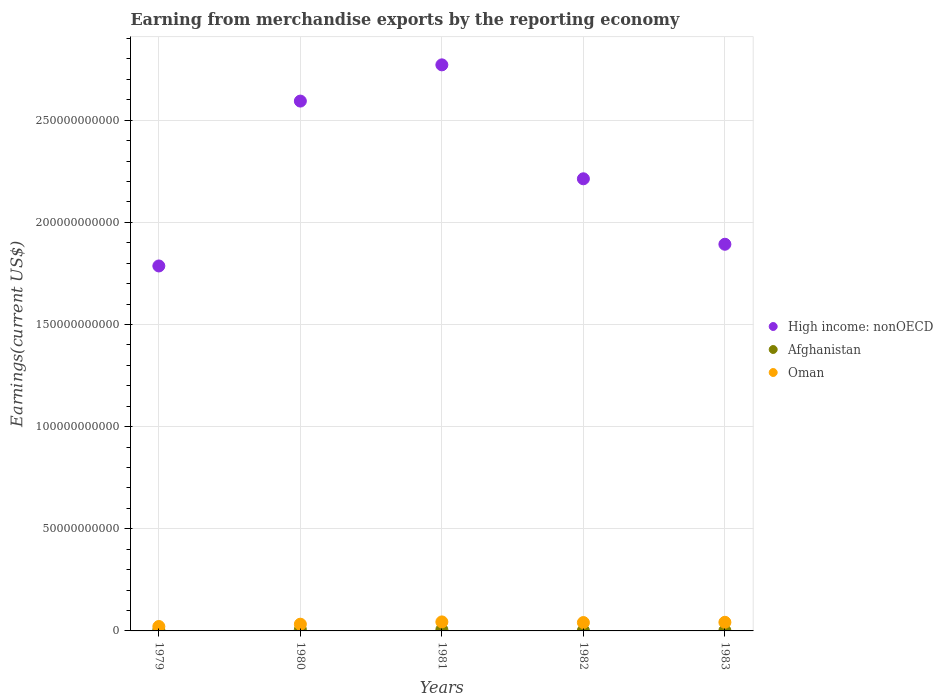Is the number of dotlines equal to the number of legend labels?
Give a very brief answer. Yes. What is the amount earned from merchandise exports in Afghanistan in 1982?
Offer a terse response. 2.01e+08. Across all years, what is the maximum amount earned from merchandise exports in Afghanistan?
Provide a succinct answer. 6.70e+08. Across all years, what is the minimum amount earned from merchandise exports in Afghanistan?
Offer a terse response. 1.95e+08. In which year was the amount earned from merchandise exports in Afghanistan minimum?
Keep it short and to the point. 1983. What is the total amount earned from merchandise exports in High income: nonOECD in the graph?
Provide a succinct answer. 1.13e+12. What is the difference between the amount earned from merchandise exports in Afghanistan in 1980 and that in 1981?
Make the answer very short. 3.24e+07. What is the difference between the amount earned from merchandise exports in High income: nonOECD in 1979 and the amount earned from merchandise exports in Afghanistan in 1980?
Provide a succinct answer. 1.78e+11. What is the average amount earned from merchandise exports in High income: nonOECD per year?
Offer a very short reply. 2.25e+11. In the year 1981, what is the difference between the amount earned from merchandise exports in High income: nonOECD and amount earned from merchandise exports in Oman?
Your response must be concise. 2.73e+11. In how many years, is the amount earned from merchandise exports in Afghanistan greater than 60000000000 US$?
Your answer should be compact. 0. What is the ratio of the amount earned from merchandise exports in High income: nonOECD in 1980 to that in 1981?
Make the answer very short. 0.94. Is the amount earned from merchandise exports in Oman in 1980 less than that in 1982?
Your answer should be compact. Yes. Is the difference between the amount earned from merchandise exports in High income: nonOECD in 1979 and 1980 greater than the difference between the amount earned from merchandise exports in Oman in 1979 and 1980?
Your response must be concise. No. What is the difference between the highest and the second highest amount earned from merchandise exports in High income: nonOECD?
Ensure brevity in your answer.  1.77e+1. What is the difference between the highest and the lowest amount earned from merchandise exports in High income: nonOECD?
Give a very brief answer. 9.84e+1. Is the sum of the amount earned from merchandise exports in Afghanistan in 1979 and 1981 greater than the maximum amount earned from merchandise exports in High income: nonOECD across all years?
Your answer should be compact. No. Does the amount earned from merchandise exports in Afghanistan monotonically increase over the years?
Ensure brevity in your answer.  No. How many years are there in the graph?
Offer a very short reply. 5. What is the difference between two consecutive major ticks on the Y-axis?
Give a very brief answer. 5.00e+1. Are the values on the major ticks of Y-axis written in scientific E-notation?
Offer a very short reply. No. Where does the legend appear in the graph?
Your answer should be very brief. Center right. How are the legend labels stacked?
Your response must be concise. Vertical. What is the title of the graph?
Offer a very short reply. Earning from merchandise exports by the reporting economy. What is the label or title of the Y-axis?
Your response must be concise. Earnings(current US$). What is the Earnings(current US$) of High income: nonOECD in 1979?
Offer a terse response. 1.79e+11. What is the Earnings(current US$) in Afghanistan in 1979?
Offer a terse response. 4.35e+08. What is the Earnings(current US$) in Oman in 1979?
Give a very brief answer. 2.17e+09. What is the Earnings(current US$) in High income: nonOECD in 1980?
Offer a very short reply. 2.59e+11. What is the Earnings(current US$) of Afghanistan in 1980?
Your answer should be very brief. 6.70e+08. What is the Earnings(current US$) of Oman in 1980?
Offer a terse response. 3.29e+09. What is the Earnings(current US$) in High income: nonOECD in 1981?
Make the answer very short. 2.77e+11. What is the Earnings(current US$) of Afghanistan in 1981?
Offer a terse response. 6.38e+08. What is the Earnings(current US$) in Oman in 1981?
Offer a terse response. 4.41e+09. What is the Earnings(current US$) of High income: nonOECD in 1982?
Your answer should be very brief. 2.21e+11. What is the Earnings(current US$) of Afghanistan in 1982?
Provide a succinct answer. 2.01e+08. What is the Earnings(current US$) of Oman in 1982?
Your answer should be compact. 4.09e+09. What is the Earnings(current US$) in High income: nonOECD in 1983?
Your answer should be compact. 1.89e+11. What is the Earnings(current US$) in Afghanistan in 1983?
Keep it short and to the point. 1.95e+08. What is the Earnings(current US$) in Oman in 1983?
Offer a very short reply. 4.22e+09. Across all years, what is the maximum Earnings(current US$) in High income: nonOECD?
Offer a terse response. 2.77e+11. Across all years, what is the maximum Earnings(current US$) in Afghanistan?
Make the answer very short. 6.70e+08. Across all years, what is the maximum Earnings(current US$) of Oman?
Offer a terse response. 4.41e+09. Across all years, what is the minimum Earnings(current US$) of High income: nonOECD?
Provide a short and direct response. 1.79e+11. Across all years, what is the minimum Earnings(current US$) in Afghanistan?
Ensure brevity in your answer.  1.95e+08. Across all years, what is the minimum Earnings(current US$) of Oman?
Keep it short and to the point. 2.17e+09. What is the total Earnings(current US$) of High income: nonOECD in the graph?
Your response must be concise. 1.13e+12. What is the total Earnings(current US$) of Afghanistan in the graph?
Your answer should be compact. 2.14e+09. What is the total Earnings(current US$) in Oman in the graph?
Offer a terse response. 1.82e+1. What is the difference between the Earnings(current US$) in High income: nonOECD in 1979 and that in 1980?
Ensure brevity in your answer.  -8.07e+1. What is the difference between the Earnings(current US$) of Afghanistan in 1979 and that in 1980?
Your answer should be very brief. -2.35e+08. What is the difference between the Earnings(current US$) in Oman in 1979 and that in 1980?
Ensure brevity in your answer.  -1.13e+09. What is the difference between the Earnings(current US$) in High income: nonOECD in 1979 and that in 1981?
Ensure brevity in your answer.  -9.84e+1. What is the difference between the Earnings(current US$) in Afghanistan in 1979 and that in 1981?
Ensure brevity in your answer.  -2.03e+08. What is the difference between the Earnings(current US$) of Oman in 1979 and that in 1981?
Make the answer very short. -2.24e+09. What is the difference between the Earnings(current US$) in High income: nonOECD in 1979 and that in 1982?
Your response must be concise. -4.27e+1. What is the difference between the Earnings(current US$) of Afghanistan in 1979 and that in 1982?
Offer a very short reply. 2.34e+08. What is the difference between the Earnings(current US$) in Oman in 1979 and that in 1982?
Ensure brevity in your answer.  -1.93e+09. What is the difference between the Earnings(current US$) of High income: nonOECD in 1979 and that in 1983?
Give a very brief answer. -1.06e+1. What is the difference between the Earnings(current US$) of Afghanistan in 1979 and that in 1983?
Your answer should be very brief. 2.40e+08. What is the difference between the Earnings(current US$) of Oman in 1979 and that in 1983?
Ensure brevity in your answer.  -2.06e+09. What is the difference between the Earnings(current US$) of High income: nonOECD in 1980 and that in 1981?
Ensure brevity in your answer.  -1.77e+1. What is the difference between the Earnings(current US$) of Afghanistan in 1980 and that in 1981?
Ensure brevity in your answer.  3.24e+07. What is the difference between the Earnings(current US$) of Oman in 1980 and that in 1981?
Offer a very short reply. -1.11e+09. What is the difference between the Earnings(current US$) of High income: nonOECD in 1980 and that in 1982?
Your response must be concise. 3.80e+1. What is the difference between the Earnings(current US$) in Afghanistan in 1980 and that in 1982?
Offer a terse response. 4.70e+08. What is the difference between the Earnings(current US$) in Oman in 1980 and that in 1982?
Offer a terse response. -8.00e+08. What is the difference between the Earnings(current US$) in High income: nonOECD in 1980 and that in 1983?
Ensure brevity in your answer.  7.01e+1. What is the difference between the Earnings(current US$) in Afghanistan in 1980 and that in 1983?
Provide a short and direct response. 4.75e+08. What is the difference between the Earnings(current US$) in Oman in 1980 and that in 1983?
Give a very brief answer. -9.28e+08. What is the difference between the Earnings(current US$) of High income: nonOECD in 1981 and that in 1982?
Your response must be concise. 5.58e+1. What is the difference between the Earnings(current US$) in Afghanistan in 1981 and that in 1982?
Make the answer very short. 4.37e+08. What is the difference between the Earnings(current US$) in Oman in 1981 and that in 1982?
Your answer should be very brief. 3.13e+08. What is the difference between the Earnings(current US$) in High income: nonOECD in 1981 and that in 1983?
Your answer should be compact. 8.78e+1. What is the difference between the Earnings(current US$) in Afghanistan in 1981 and that in 1983?
Make the answer very short. 4.43e+08. What is the difference between the Earnings(current US$) of Oman in 1981 and that in 1983?
Keep it short and to the point. 1.84e+08. What is the difference between the Earnings(current US$) in High income: nonOECD in 1982 and that in 1983?
Provide a short and direct response. 3.20e+1. What is the difference between the Earnings(current US$) of Afghanistan in 1982 and that in 1983?
Your answer should be very brief. 5.49e+06. What is the difference between the Earnings(current US$) of Oman in 1982 and that in 1983?
Your answer should be very brief. -1.28e+08. What is the difference between the Earnings(current US$) in High income: nonOECD in 1979 and the Earnings(current US$) in Afghanistan in 1980?
Provide a short and direct response. 1.78e+11. What is the difference between the Earnings(current US$) of High income: nonOECD in 1979 and the Earnings(current US$) of Oman in 1980?
Ensure brevity in your answer.  1.75e+11. What is the difference between the Earnings(current US$) in Afghanistan in 1979 and the Earnings(current US$) in Oman in 1980?
Make the answer very short. -2.86e+09. What is the difference between the Earnings(current US$) in High income: nonOECD in 1979 and the Earnings(current US$) in Afghanistan in 1981?
Your answer should be very brief. 1.78e+11. What is the difference between the Earnings(current US$) of High income: nonOECD in 1979 and the Earnings(current US$) of Oman in 1981?
Provide a succinct answer. 1.74e+11. What is the difference between the Earnings(current US$) in Afghanistan in 1979 and the Earnings(current US$) in Oman in 1981?
Your answer should be compact. -3.97e+09. What is the difference between the Earnings(current US$) in High income: nonOECD in 1979 and the Earnings(current US$) in Afghanistan in 1982?
Your response must be concise. 1.78e+11. What is the difference between the Earnings(current US$) in High income: nonOECD in 1979 and the Earnings(current US$) in Oman in 1982?
Make the answer very short. 1.75e+11. What is the difference between the Earnings(current US$) of Afghanistan in 1979 and the Earnings(current US$) of Oman in 1982?
Your answer should be very brief. -3.66e+09. What is the difference between the Earnings(current US$) of High income: nonOECD in 1979 and the Earnings(current US$) of Afghanistan in 1983?
Make the answer very short. 1.78e+11. What is the difference between the Earnings(current US$) in High income: nonOECD in 1979 and the Earnings(current US$) in Oman in 1983?
Provide a succinct answer. 1.74e+11. What is the difference between the Earnings(current US$) in Afghanistan in 1979 and the Earnings(current US$) in Oman in 1983?
Your answer should be very brief. -3.79e+09. What is the difference between the Earnings(current US$) in High income: nonOECD in 1980 and the Earnings(current US$) in Afghanistan in 1981?
Keep it short and to the point. 2.59e+11. What is the difference between the Earnings(current US$) in High income: nonOECD in 1980 and the Earnings(current US$) in Oman in 1981?
Your answer should be very brief. 2.55e+11. What is the difference between the Earnings(current US$) in Afghanistan in 1980 and the Earnings(current US$) in Oman in 1981?
Your response must be concise. -3.74e+09. What is the difference between the Earnings(current US$) of High income: nonOECD in 1980 and the Earnings(current US$) of Afghanistan in 1982?
Give a very brief answer. 2.59e+11. What is the difference between the Earnings(current US$) in High income: nonOECD in 1980 and the Earnings(current US$) in Oman in 1982?
Provide a short and direct response. 2.55e+11. What is the difference between the Earnings(current US$) of Afghanistan in 1980 and the Earnings(current US$) of Oman in 1982?
Give a very brief answer. -3.42e+09. What is the difference between the Earnings(current US$) in High income: nonOECD in 1980 and the Earnings(current US$) in Afghanistan in 1983?
Your answer should be very brief. 2.59e+11. What is the difference between the Earnings(current US$) in High income: nonOECD in 1980 and the Earnings(current US$) in Oman in 1983?
Your answer should be very brief. 2.55e+11. What is the difference between the Earnings(current US$) of Afghanistan in 1980 and the Earnings(current US$) of Oman in 1983?
Your answer should be compact. -3.55e+09. What is the difference between the Earnings(current US$) in High income: nonOECD in 1981 and the Earnings(current US$) in Afghanistan in 1982?
Ensure brevity in your answer.  2.77e+11. What is the difference between the Earnings(current US$) in High income: nonOECD in 1981 and the Earnings(current US$) in Oman in 1982?
Ensure brevity in your answer.  2.73e+11. What is the difference between the Earnings(current US$) in Afghanistan in 1981 and the Earnings(current US$) in Oman in 1982?
Your answer should be compact. -3.46e+09. What is the difference between the Earnings(current US$) in High income: nonOECD in 1981 and the Earnings(current US$) in Afghanistan in 1983?
Keep it short and to the point. 2.77e+11. What is the difference between the Earnings(current US$) in High income: nonOECD in 1981 and the Earnings(current US$) in Oman in 1983?
Ensure brevity in your answer.  2.73e+11. What is the difference between the Earnings(current US$) of Afghanistan in 1981 and the Earnings(current US$) of Oman in 1983?
Your answer should be compact. -3.58e+09. What is the difference between the Earnings(current US$) of High income: nonOECD in 1982 and the Earnings(current US$) of Afghanistan in 1983?
Your answer should be compact. 2.21e+11. What is the difference between the Earnings(current US$) in High income: nonOECD in 1982 and the Earnings(current US$) in Oman in 1983?
Give a very brief answer. 2.17e+11. What is the difference between the Earnings(current US$) of Afghanistan in 1982 and the Earnings(current US$) of Oman in 1983?
Your response must be concise. -4.02e+09. What is the average Earnings(current US$) of High income: nonOECD per year?
Keep it short and to the point. 2.25e+11. What is the average Earnings(current US$) of Afghanistan per year?
Your response must be concise. 4.28e+08. What is the average Earnings(current US$) in Oman per year?
Make the answer very short. 3.64e+09. In the year 1979, what is the difference between the Earnings(current US$) in High income: nonOECD and Earnings(current US$) in Afghanistan?
Make the answer very short. 1.78e+11. In the year 1979, what is the difference between the Earnings(current US$) in High income: nonOECD and Earnings(current US$) in Oman?
Give a very brief answer. 1.76e+11. In the year 1979, what is the difference between the Earnings(current US$) in Afghanistan and Earnings(current US$) in Oman?
Give a very brief answer. -1.73e+09. In the year 1980, what is the difference between the Earnings(current US$) of High income: nonOECD and Earnings(current US$) of Afghanistan?
Ensure brevity in your answer.  2.59e+11. In the year 1980, what is the difference between the Earnings(current US$) of High income: nonOECD and Earnings(current US$) of Oman?
Provide a short and direct response. 2.56e+11. In the year 1980, what is the difference between the Earnings(current US$) in Afghanistan and Earnings(current US$) in Oman?
Your response must be concise. -2.62e+09. In the year 1981, what is the difference between the Earnings(current US$) in High income: nonOECD and Earnings(current US$) in Afghanistan?
Your response must be concise. 2.76e+11. In the year 1981, what is the difference between the Earnings(current US$) of High income: nonOECD and Earnings(current US$) of Oman?
Make the answer very short. 2.73e+11. In the year 1981, what is the difference between the Earnings(current US$) of Afghanistan and Earnings(current US$) of Oman?
Your answer should be very brief. -3.77e+09. In the year 1982, what is the difference between the Earnings(current US$) of High income: nonOECD and Earnings(current US$) of Afghanistan?
Your answer should be compact. 2.21e+11. In the year 1982, what is the difference between the Earnings(current US$) of High income: nonOECD and Earnings(current US$) of Oman?
Ensure brevity in your answer.  2.17e+11. In the year 1982, what is the difference between the Earnings(current US$) of Afghanistan and Earnings(current US$) of Oman?
Offer a very short reply. -3.89e+09. In the year 1983, what is the difference between the Earnings(current US$) in High income: nonOECD and Earnings(current US$) in Afghanistan?
Your answer should be very brief. 1.89e+11. In the year 1983, what is the difference between the Earnings(current US$) in High income: nonOECD and Earnings(current US$) in Oman?
Provide a succinct answer. 1.85e+11. In the year 1983, what is the difference between the Earnings(current US$) of Afghanistan and Earnings(current US$) of Oman?
Ensure brevity in your answer.  -4.03e+09. What is the ratio of the Earnings(current US$) in High income: nonOECD in 1979 to that in 1980?
Your answer should be compact. 0.69. What is the ratio of the Earnings(current US$) in Afghanistan in 1979 to that in 1980?
Offer a very short reply. 0.65. What is the ratio of the Earnings(current US$) of Oman in 1979 to that in 1980?
Provide a short and direct response. 0.66. What is the ratio of the Earnings(current US$) in High income: nonOECD in 1979 to that in 1981?
Your response must be concise. 0.64. What is the ratio of the Earnings(current US$) of Afghanistan in 1979 to that in 1981?
Your answer should be very brief. 0.68. What is the ratio of the Earnings(current US$) of Oman in 1979 to that in 1981?
Provide a succinct answer. 0.49. What is the ratio of the Earnings(current US$) in High income: nonOECD in 1979 to that in 1982?
Your response must be concise. 0.81. What is the ratio of the Earnings(current US$) of Afghanistan in 1979 to that in 1982?
Offer a terse response. 2.17. What is the ratio of the Earnings(current US$) of Oman in 1979 to that in 1982?
Offer a very short reply. 0.53. What is the ratio of the Earnings(current US$) in High income: nonOECD in 1979 to that in 1983?
Your answer should be very brief. 0.94. What is the ratio of the Earnings(current US$) of Afghanistan in 1979 to that in 1983?
Provide a short and direct response. 2.23. What is the ratio of the Earnings(current US$) in Oman in 1979 to that in 1983?
Provide a short and direct response. 0.51. What is the ratio of the Earnings(current US$) in High income: nonOECD in 1980 to that in 1981?
Provide a short and direct response. 0.94. What is the ratio of the Earnings(current US$) of Afghanistan in 1980 to that in 1981?
Give a very brief answer. 1.05. What is the ratio of the Earnings(current US$) in Oman in 1980 to that in 1981?
Make the answer very short. 0.75. What is the ratio of the Earnings(current US$) in High income: nonOECD in 1980 to that in 1982?
Offer a terse response. 1.17. What is the ratio of the Earnings(current US$) in Afghanistan in 1980 to that in 1982?
Ensure brevity in your answer.  3.34. What is the ratio of the Earnings(current US$) of Oman in 1980 to that in 1982?
Make the answer very short. 0.8. What is the ratio of the Earnings(current US$) in High income: nonOECD in 1980 to that in 1983?
Your answer should be very brief. 1.37. What is the ratio of the Earnings(current US$) of Afghanistan in 1980 to that in 1983?
Provide a succinct answer. 3.43. What is the ratio of the Earnings(current US$) in Oman in 1980 to that in 1983?
Offer a terse response. 0.78. What is the ratio of the Earnings(current US$) in High income: nonOECD in 1981 to that in 1982?
Give a very brief answer. 1.25. What is the ratio of the Earnings(current US$) of Afghanistan in 1981 to that in 1982?
Your answer should be compact. 3.18. What is the ratio of the Earnings(current US$) of Oman in 1981 to that in 1982?
Your response must be concise. 1.08. What is the ratio of the Earnings(current US$) in High income: nonOECD in 1981 to that in 1983?
Your response must be concise. 1.46. What is the ratio of the Earnings(current US$) of Afghanistan in 1981 to that in 1983?
Your answer should be very brief. 3.27. What is the ratio of the Earnings(current US$) in Oman in 1981 to that in 1983?
Your answer should be compact. 1.04. What is the ratio of the Earnings(current US$) in High income: nonOECD in 1982 to that in 1983?
Make the answer very short. 1.17. What is the ratio of the Earnings(current US$) in Afghanistan in 1982 to that in 1983?
Your answer should be compact. 1.03. What is the ratio of the Earnings(current US$) in Oman in 1982 to that in 1983?
Your answer should be very brief. 0.97. What is the difference between the highest and the second highest Earnings(current US$) in High income: nonOECD?
Your answer should be very brief. 1.77e+1. What is the difference between the highest and the second highest Earnings(current US$) in Afghanistan?
Provide a short and direct response. 3.24e+07. What is the difference between the highest and the second highest Earnings(current US$) of Oman?
Provide a short and direct response. 1.84e+08. What is the difference between the highest and the lowest Earnings(current US$) of High income: nonOECD?
Your answer should be compact. 9.84e+1. What is the difference between the highest and the lowest Earnings(current US$) in Afghanistan?
Give a very brief answer. 4.75e+08. What is the difference between the highest and the lowest Earnings(current US$) in Oman?
Your answer should be very brief. 2.24e+09. 